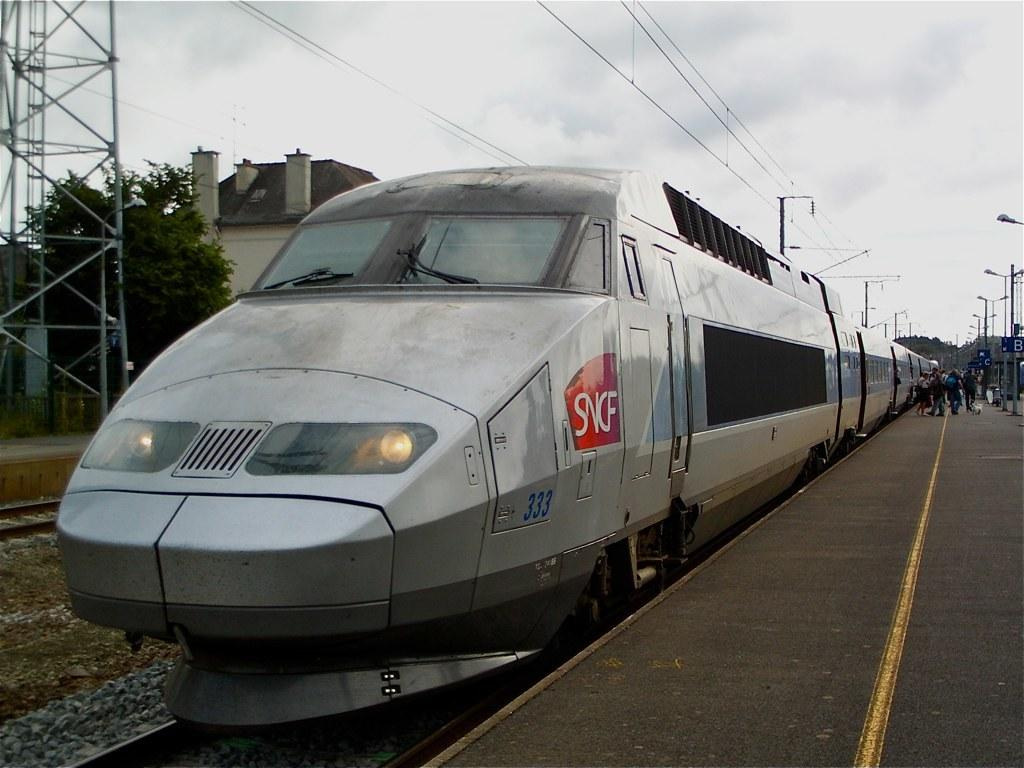What type of structure can be seen in the image? There is a platform in the image. What are some other objects present in the image? Light poles, boards, a tree, train tracks, people, a train, the sky, buildings, and rods are visible in the image. What is the condition of the sky in the image? The sky is cloudy in the image. What is written on the train? Something is written on the train. How many roses can be seen growing on the neck of the person in the image? There are no roses or people with necks visible in the image. Are there any boats present in the image? There are no boats present in the image. 